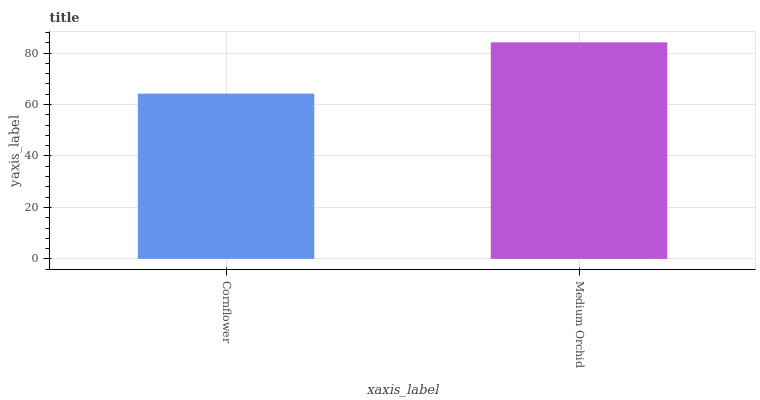Is Medium Orchid the minimum?
Answer yes or no. No. Is Medium Orchid greater than Cornflower?
Answer yes or no. Yes. Is Cornflower less than Medium Orchid?
Answer yes or no. Yes. Is Cornflower greater than Medium Orchid?
Answer yes or no. No. Is Medium Orchid less than Cornflower?
Answer yes or no. No. Is Medium Orchid the high median?
Answer yes or no. Yes. Is Cornflower the low median?
Answer yes or no. Yes. Is Cornflower the high median?
Answer yes or no. No. Is Medium Orchid the low median?
Answer yes or no. No. 